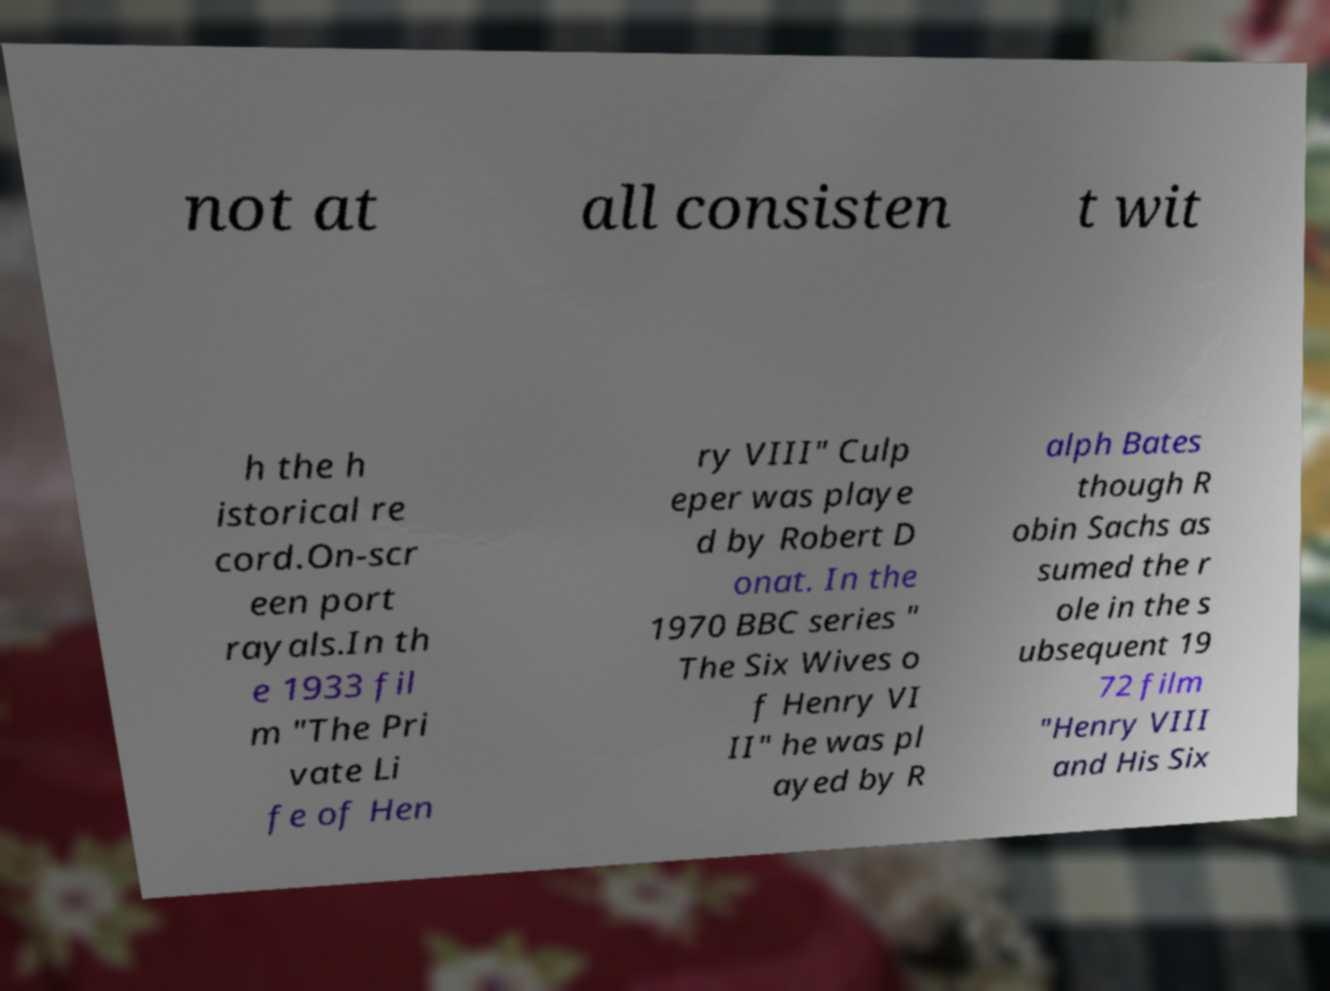What messages or text are displayed in this image? I need them in a readable, typed format. not at all consisten t wit h the h istorical re cord.On-scr een port rayals.In th e 1933 fil m "The Pri vate Li fe of Hen ry VIII" Culp eper was playe d by Robert D onat. In the 1970 BBC series " The Six Wives o f Henry VI II" he was pl ayed by R alph Bates though R obin Sachs as sumed the r ole in the s ubsequent 19 72 film "Henry VIII and His Six 